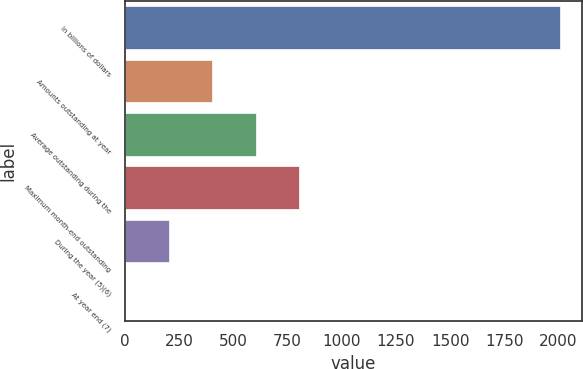<chart> <loc_0><loc_0><loc_500><loc_500><bar_chart><fcel>In billions of dollars<fcel>Amounts outstanding at year<fcel>Average outstanding during the<fcel>Maximum month-end outstanding<fcel>During the year (5)(6)<fcel>At year end (7)<nl><fcel>2008<fcel>403.38<fcel>603.96<fcel>804.54<fcel>202.8<fcel>2.22<nl></chart> 